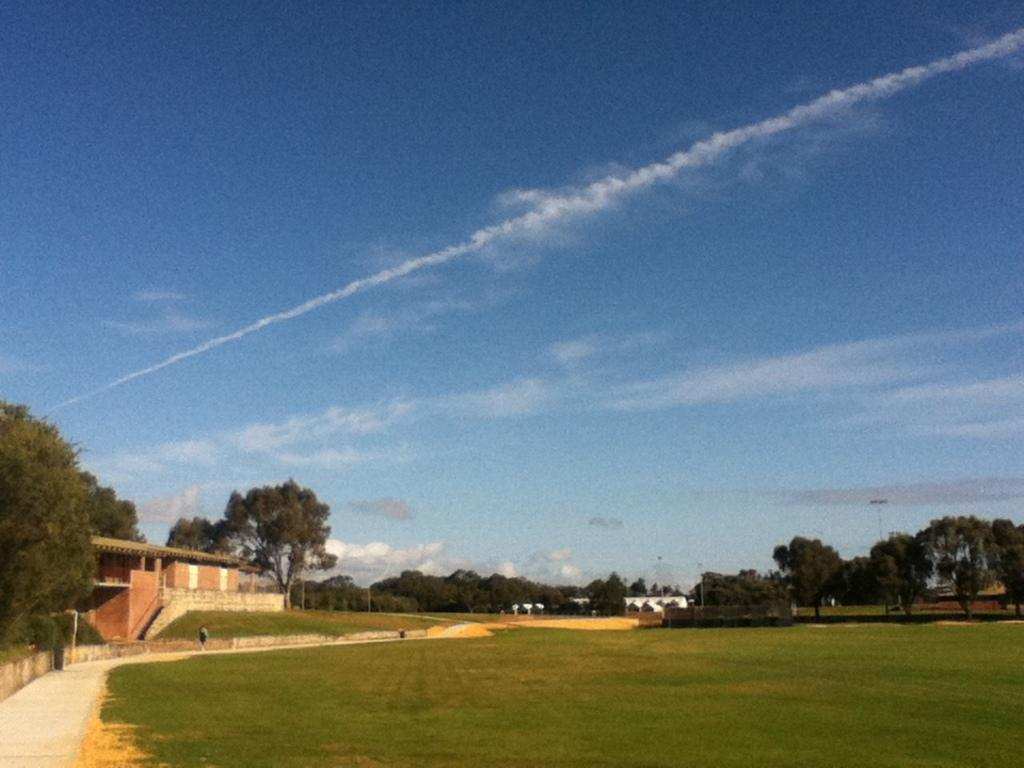Who is present in the image? There is a man in the image. What is located beside the man? There are trees beside the man. What type of structure can be seen in the image? There is a house in the image. What is present in the background of the image? There is a pole and clouds visible in the background of the image. What color of paint is the man using on his neck in the image? There is no paint or mention of the man's neck in the image. 